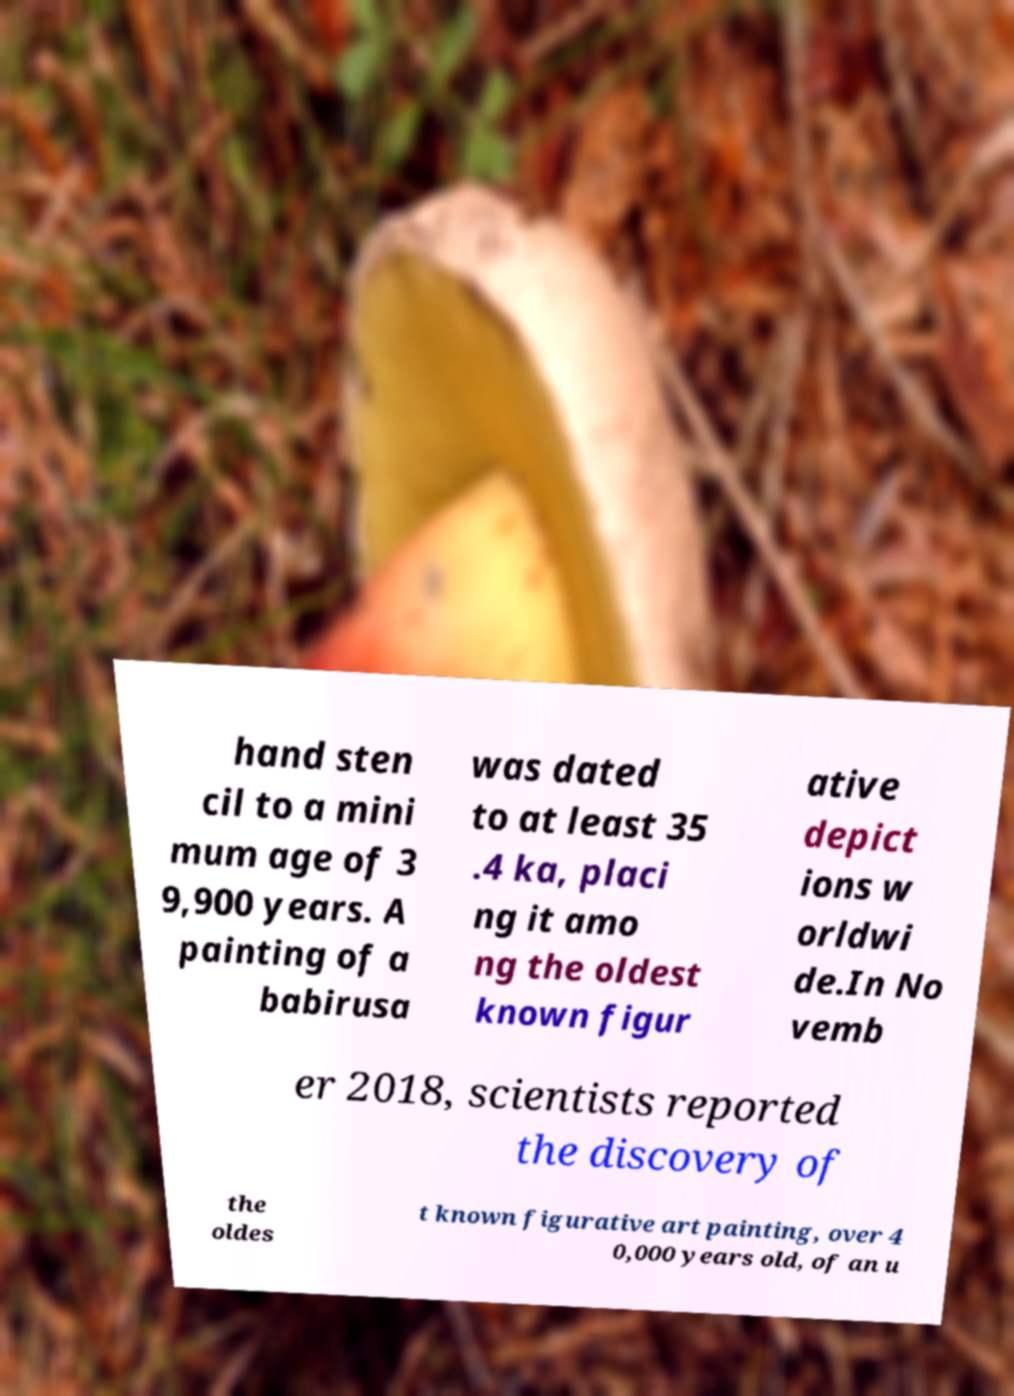Could you assist in decoding the text presented in this image and type it out clearly? hand sten cil to a mini mum age of 3 9,900 years. A painting of a babirusa was dated to at least 35 .4 ka, placi ng it amo ng the oldest known figur ative depict ions w orldwi de.In No vemb er 2018, scientists reported the discovery of the oldes t known figurative art painting, over 4 0,000 years old, of an u 